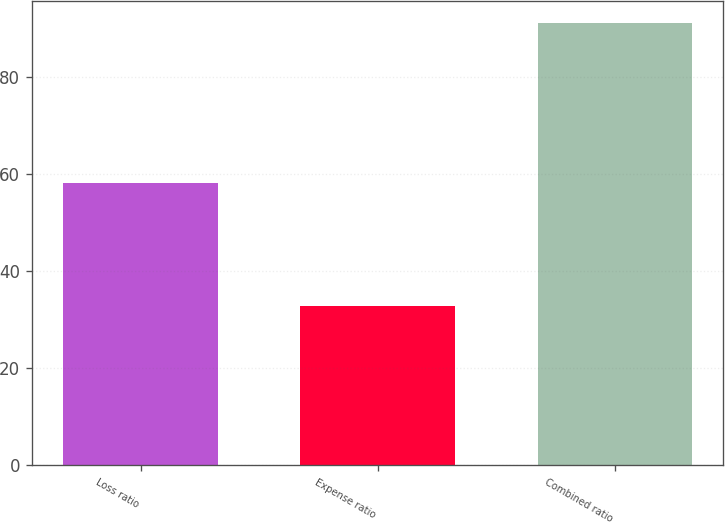Convert chart. <chart><loc_0><loc_0><loc_500><loc_500><bar_chart><fcel>Loss ratio<fcel>Expense ratio<fcel>Combined ratio<nl><fcel>58.3<fcel>32.9<fcel>91.2<nl></chart> 